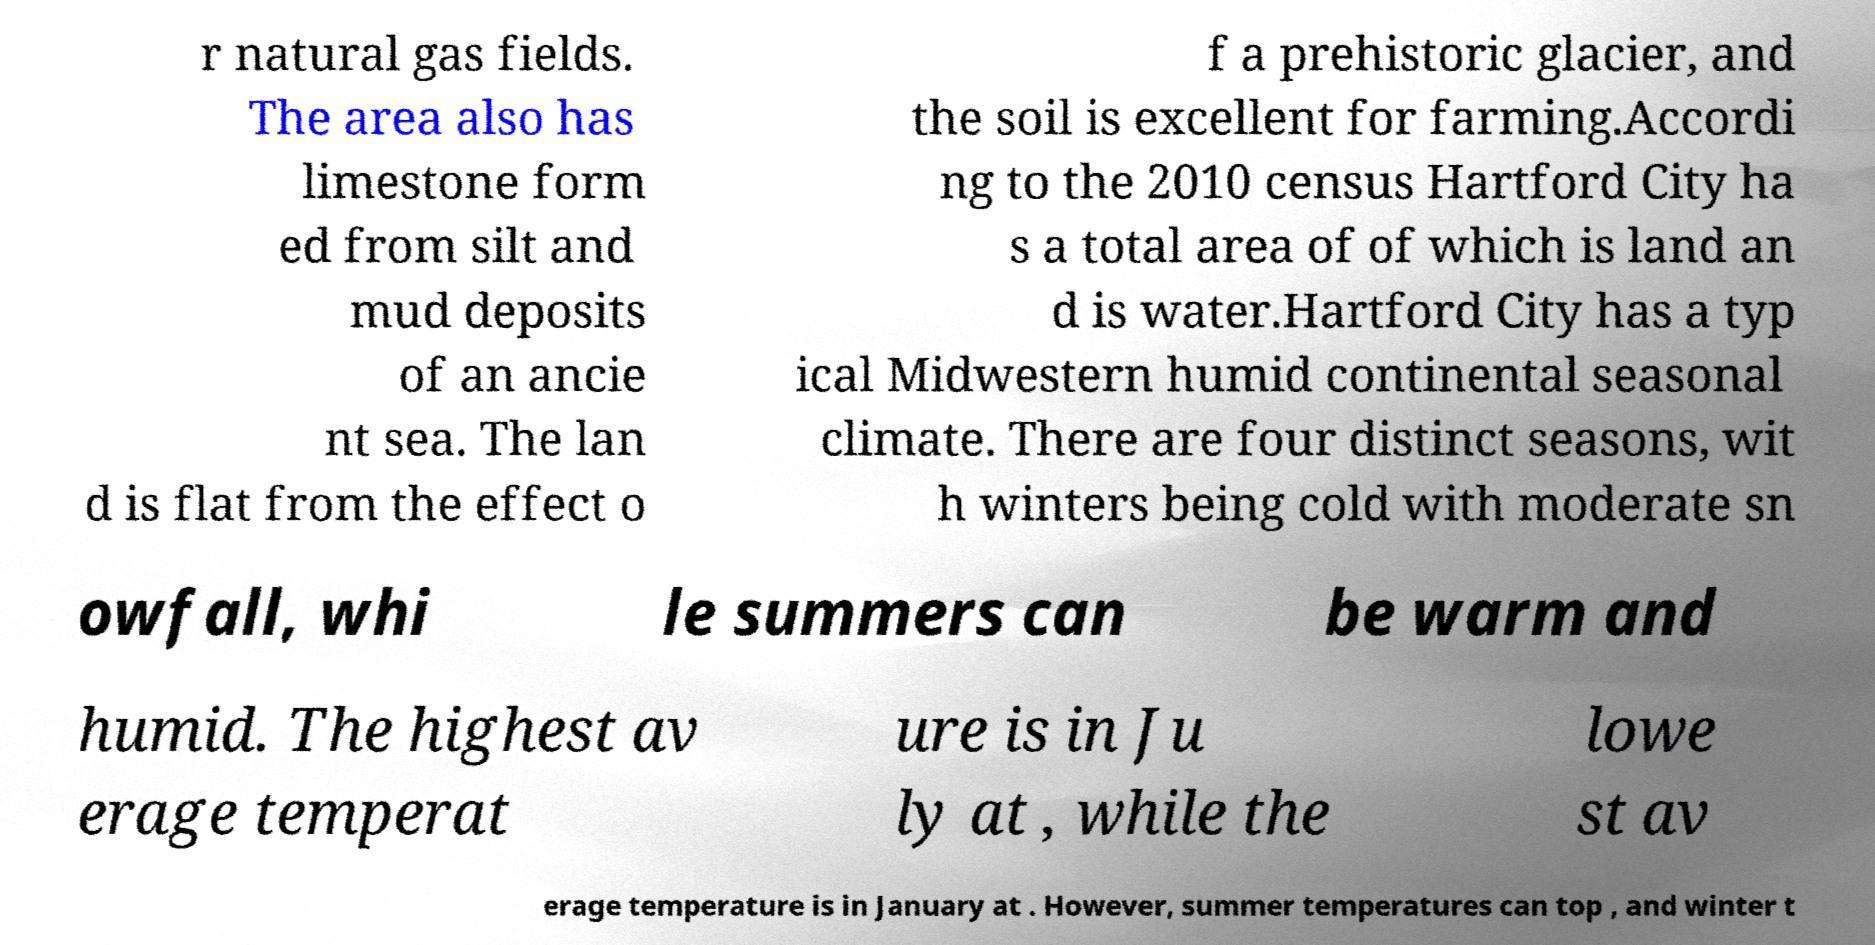Please read and relay the text visible in this image. What does it say? r natural gas fields. The area also has limestone form ed from silt and mud deposits of an ancie nt sea. The lan d is flat from the effect o f a prehistoric glacier, and the soil is excellent for farming.Accordi ng to the 2010 census Hartford City ha s a total area of of which is land an d is water.Hartford City has a typ ical Midwestern humid continental seasonal climate. There are four distinct seasons, wit h winters being cold with moderate sn owfall, whi le summers can be warm and humid. The highest av erage temperat ure is in Ju ly at , while the lowe st av erage temperature is in January at . However, summer temperatures can top , and winter t 